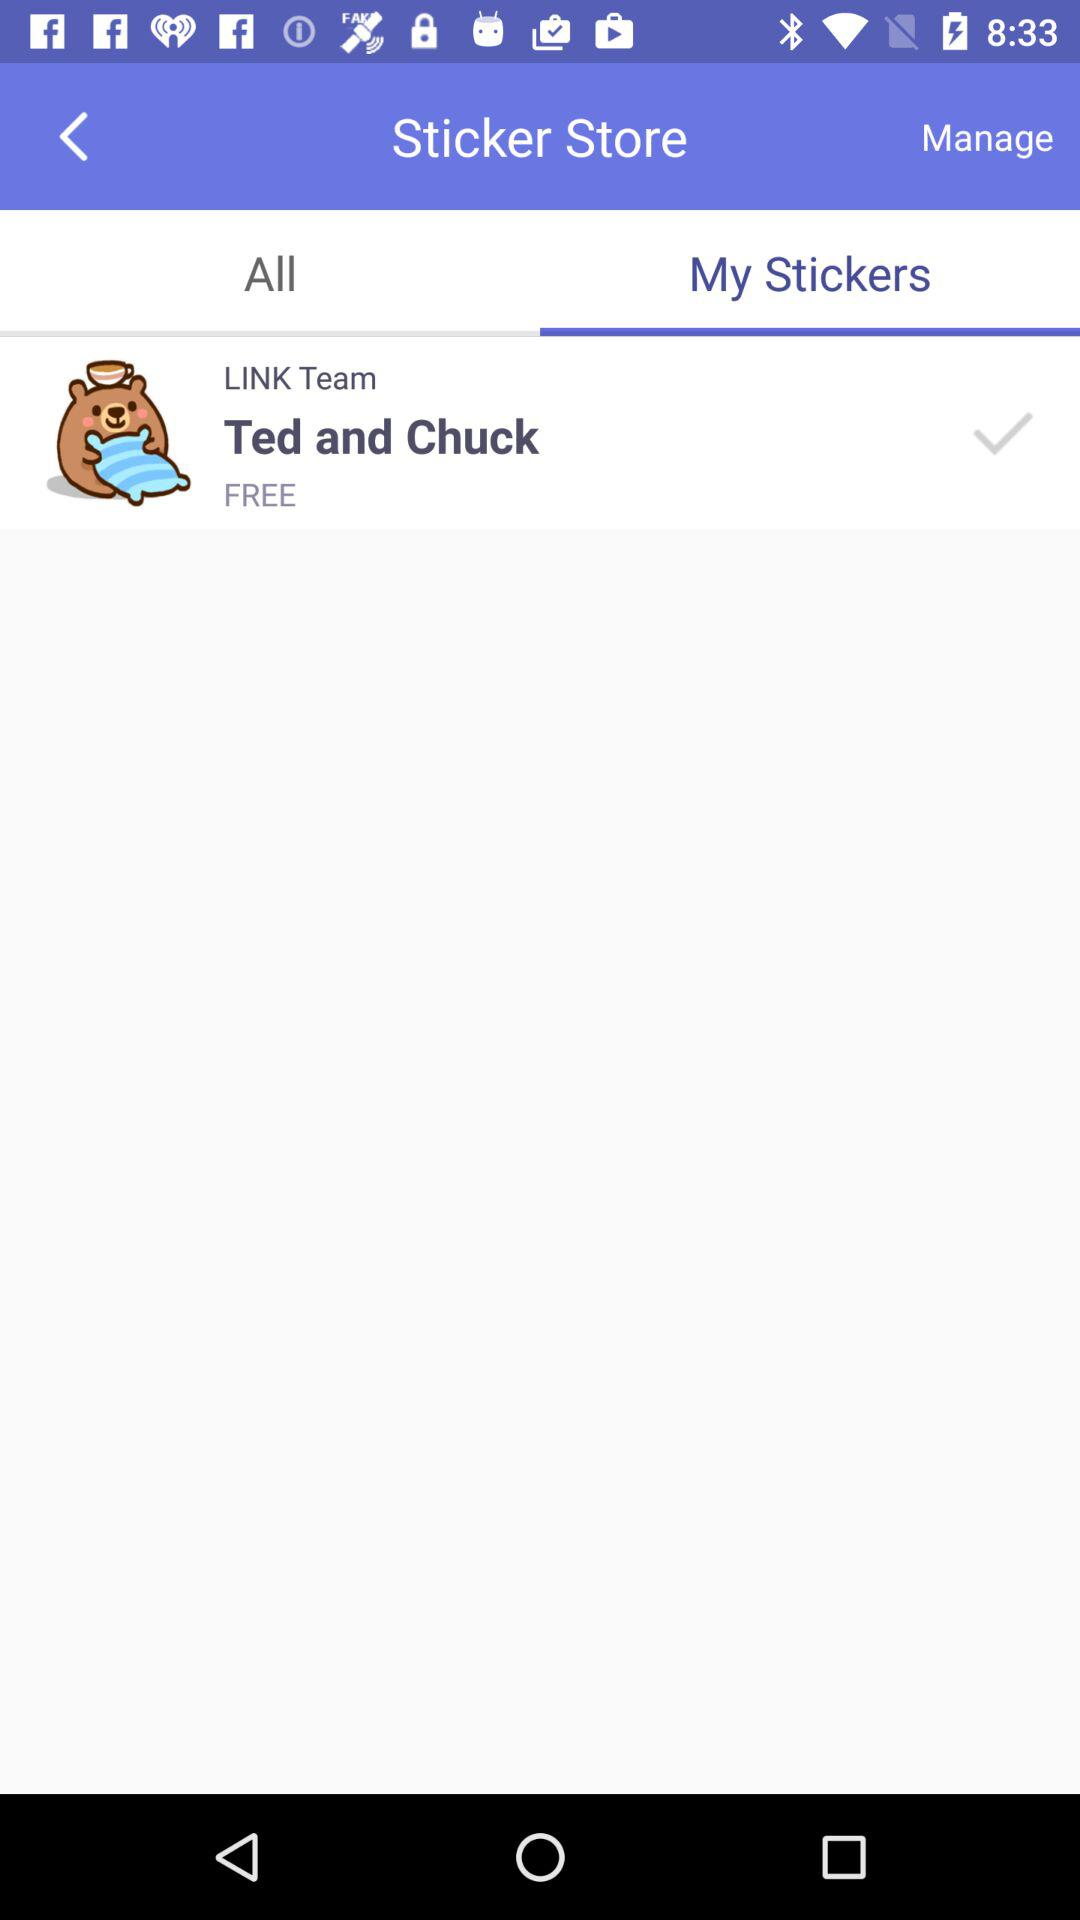What stickers are available in my stickers? The sticker available is "Ted and Chuck". 